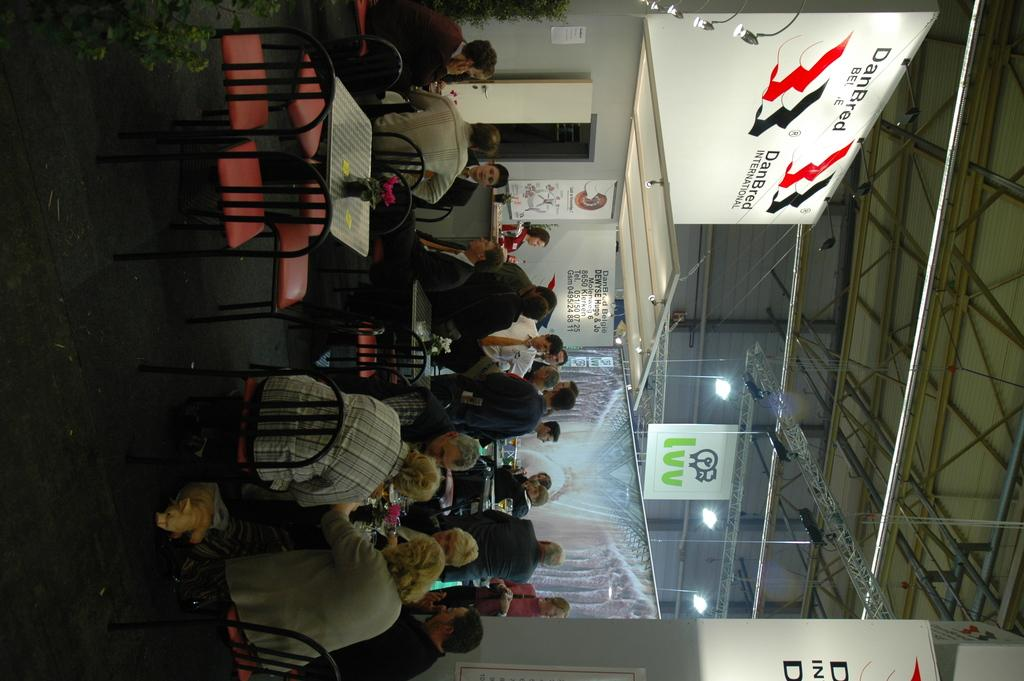What can be seen in the image? There are people in the image. What type of furniture is present in the image? There are chairs and tables in the image. What is the background of the image? There is a wall in the image. What type of decorations are visible in the image? There are banners in the image. What type of religion is being practiced by the people in the image? There is no indication of any religious practice in the image. Can you tell me how many cattle are present in the image? There are no cattle present in the image. 